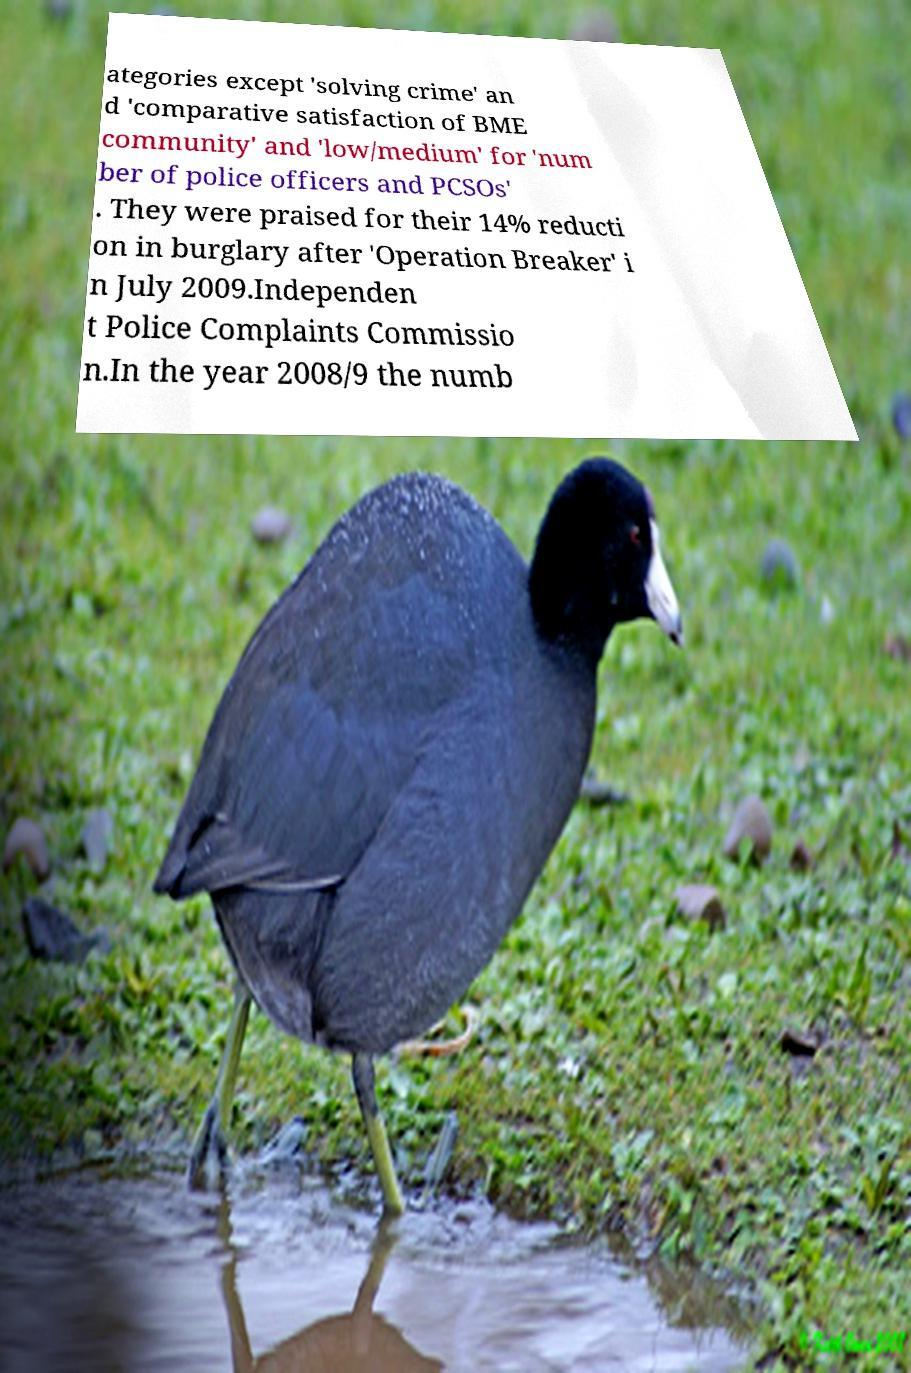I need the written content from this picture converted into text. Can you do that? ategories except 'solving crime' an d 'comparative satisfaction of BME community' and 'low/medium' for 'num ber of police officers and PCSOs' . They were praised for their 14% reducti on in burglary after 'Operation Breaker' i n July 2009.Independen t Police Complaints Commissio n.In the year 2008/9 the numb 